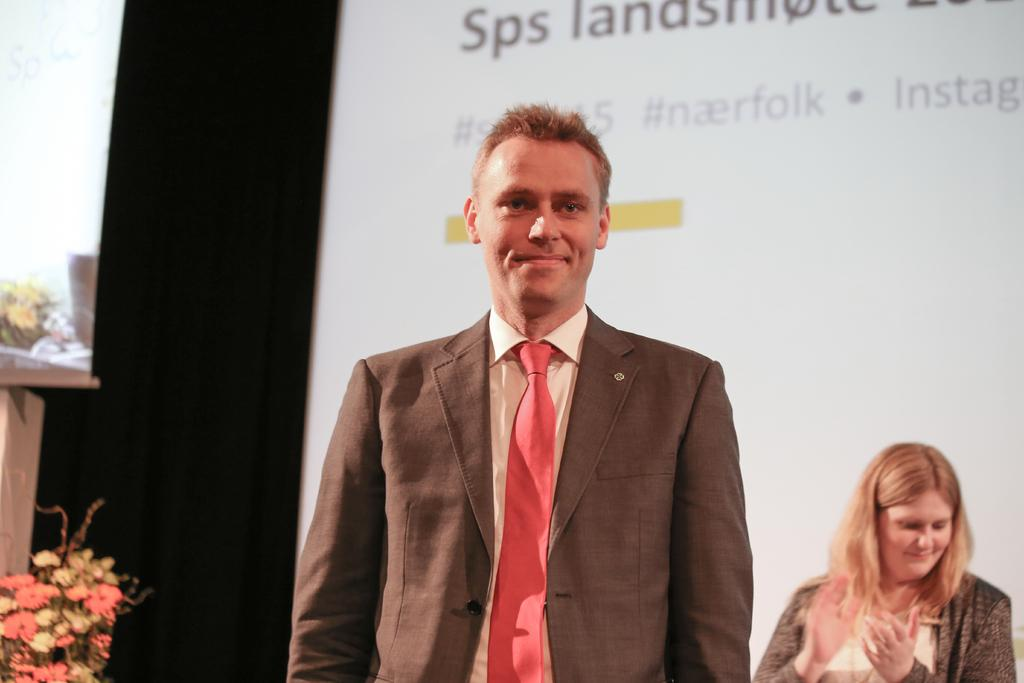Who are the people in the image? There is a man and a woman standing in the image. What can be seen on the left side of the image? There is a group of flowers on the left side of the image. What is visible in the background of the image? There are screens with text in the background of the image. What type of tail can be seen on the man in the image? There is no tail present on the man in the image. How many bodies are visible in the image? There are two bodies visible in the image, corresponding to the man and the woman. 